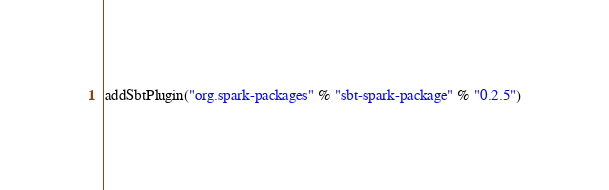Convert code to text. <code><loc_0><loc_0><loc_500><loc_500><_Scala_>addSbtPlugin("org.spark-packages" % "sbt-spark-package" % "0.2.5")
</code> 